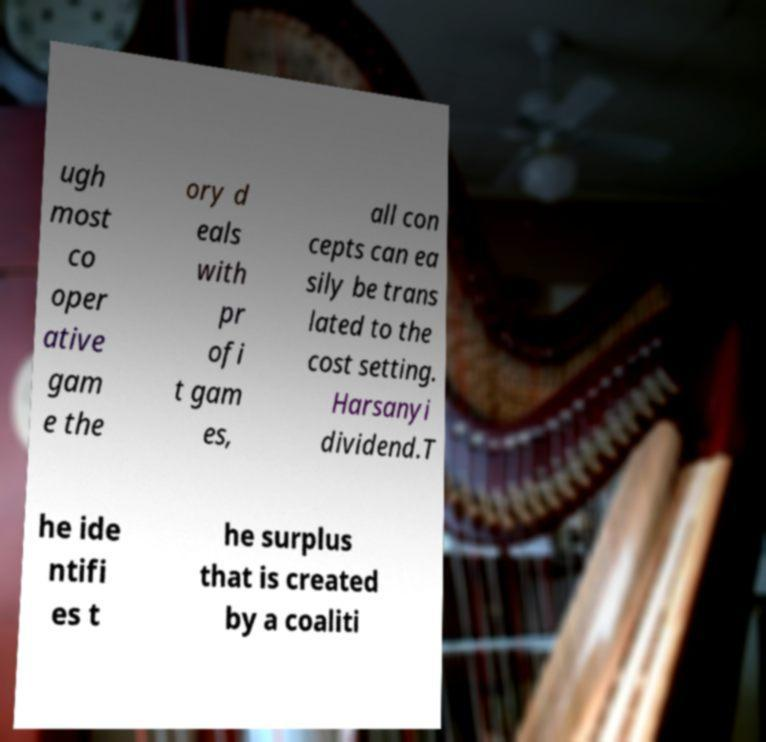Could you assist in decoding the text presented in this image and type it out clearly? ugh most co oper ative gam e the ory d eals with pr ofi t gam es, all con cepts can ea sily be trans lated to the cost setting. Harsanyi dividend.T he ide ntifi es t he surplus that is created by a coaliti 